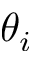Convert formula to latex. <formula><loc_0><loc_0><loc_500><loc_500>\theta _ { i }</formula> 